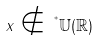<formula> <loc_0><loc_0><loc_500><loc_500>x \notin \, ^ { ^ { * } } \mathbb { U } ( \mathbb { R } )</formula> 